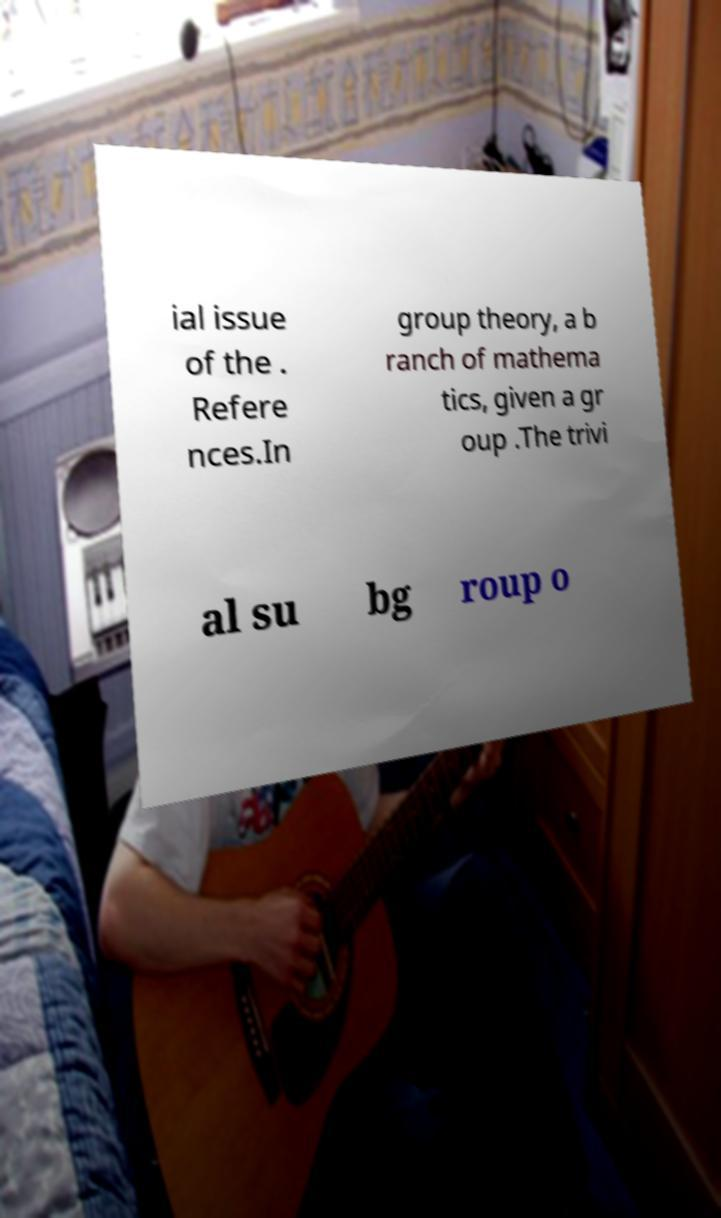Please identify and transcribe the text found in this image. ial issue of the . Refere nces.In group theory, a b ranch of mathema tics, given a gr oup .The trivi al su bg roup o 